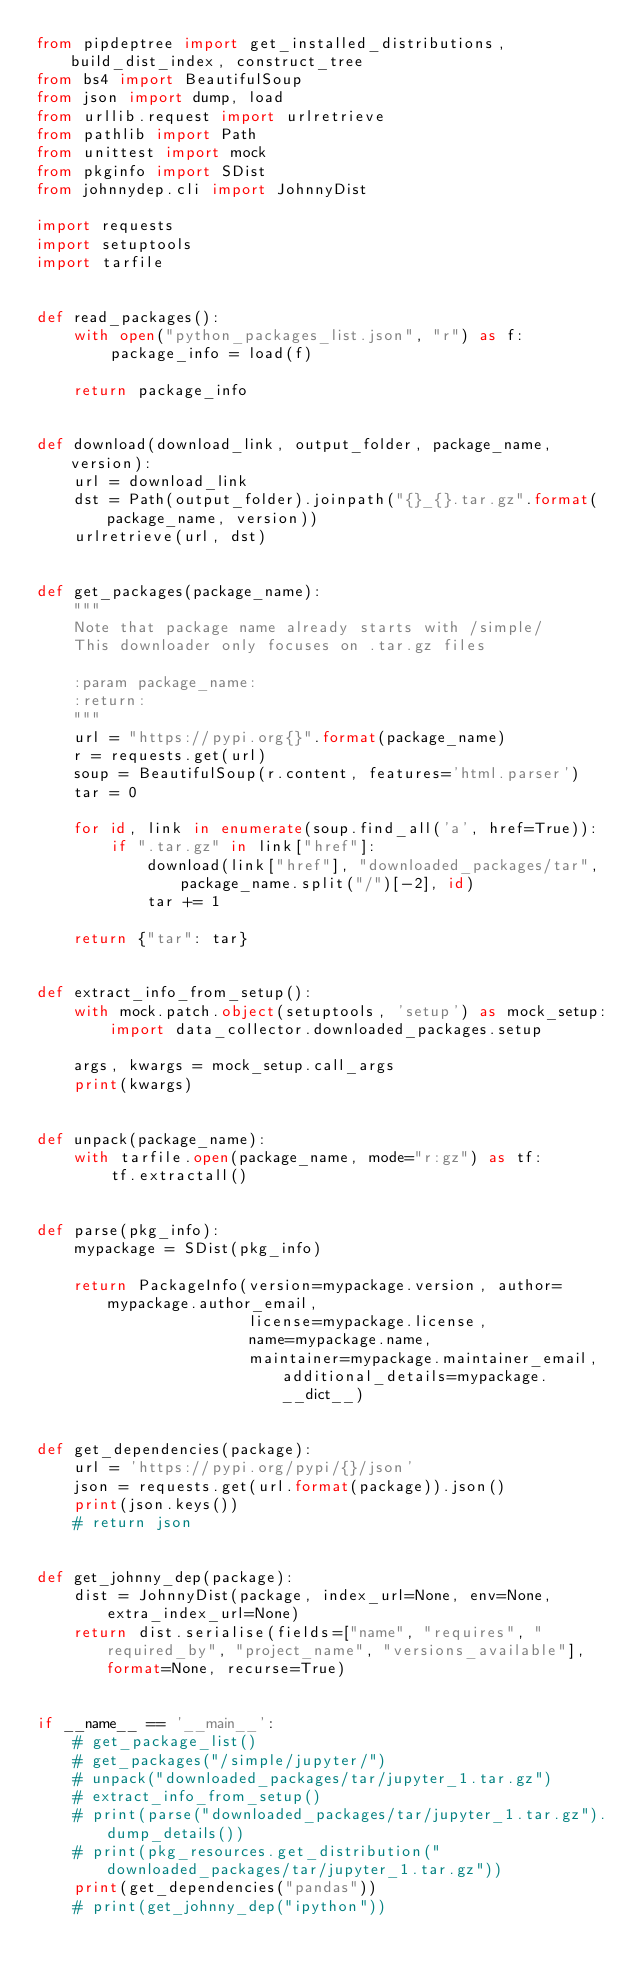<code> <loc_0><loc_0><loc_500><loc_500><_Python_>from pipdeptree import get_installed_distributions, build_dist_index, construct_tree
from bs4 import BeautifulSoup
from json import dump, load
from urllib.request import urlretrieve
from pathlib import Path
from unittest import mock
from pkginfo import SDist
from johnnydep.cli import JohnnyDist

import requests
import setuptools
import tarfile


def read_packages():
    with open("python_packages_list.json", "r") as f:
        package_info = load(f)

    return package_info


def download(download_link, output_folder, package_name, version):
    url = download_link
    dst = Path(output_folder).joinpath("{}_{}.tar.gz".format(package_name, version))
    urlretrieve(url, dst)


def get_packages(package_name):
    """
    Note that package name already starts with /simple/
    This downloader only focuses on .tar.gz files

    :param package_name:
    :return:
    """
    url = "https://pypi.org{}".format(package_name)
    r = requests.get(url)
    soup = BeautifulSoup(r.content, features='html.parser')
    tar = 0

    for id, link in enumerate(soup.find_all('a', href=True)):
        if ".tar.gz" in link["href"]:
            download(link["href"], "downloaded_packages/tar", package_name.split("/")[-2], id)
            tar += 1

    return {"tar": tar}


def extract_info_from_setup():
    with mock.patch.object(setuptools, 'setup') as mock_setup:
        import data_collector.downloaded_packages.setup

    args, kwargs = mock_setup.call_args
    print(kwargs)


def unpack(package_name):
    with tarfile.open(package_name, mode="r:gz") as tf:
        tf.extractall()


def parse(pkg_info):
    mypackage = SDist(pkg_info)

    return PackageInfo(version=mypackage.version, author=mypackage.author_email,
                       license=mypackage.license,
                       name=mypackage.name,
                       maintainer=mypackage.maintainer_email, additional_details=mypackage.__dict__)


def get_dependencies(package):
    url = 'https://pypi.org/pypi/{}/json'
    json = requests.get(url.format(package)).json()
    print(json.keys())
    # return json


def get_johnny_dep(package):
    dist = JohnnyDist(package, index_url=None, env=None, extra_index_url=None)
    return dist.serialise(fields=["name", "requires", "required_by", "project_name", "versions_available"], format=None, recurse=True)


if __name__ == '__main__':
    # get_package_list()
    # get_packages("/simple/jupyter/")
    # unpack("downloaded_packages/tar/jupyter_1.tar.gz")
    # extract_info_from_setup()
    # print(parse("downloaded_packages/tar/jupyter_1.tar.gz").dump_details())
    # print(pkg_resources.get_distribution("downloaded_packages/tar/jupyter_1.tar.gz"))
    print(get_dependencies("pandas"))
    # print(get_johnny_dep("ipython"))

</code> 